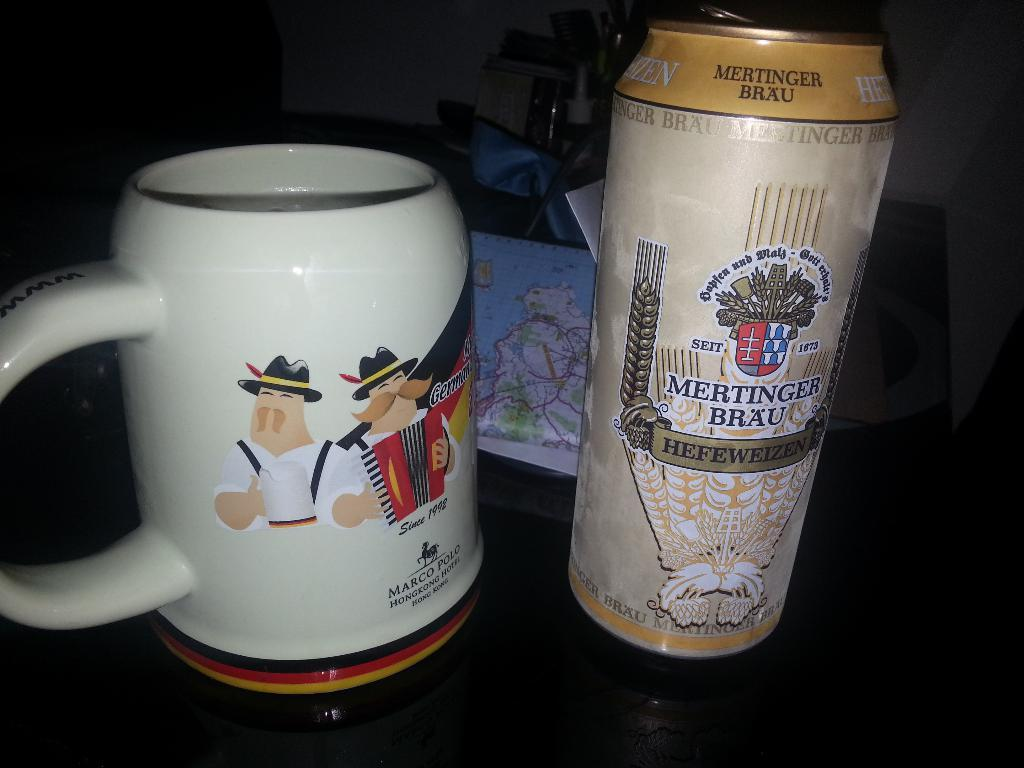<image>
Render a clear and concise summary of the photo. A can of Mertinger Brau is placed next to a mug. 